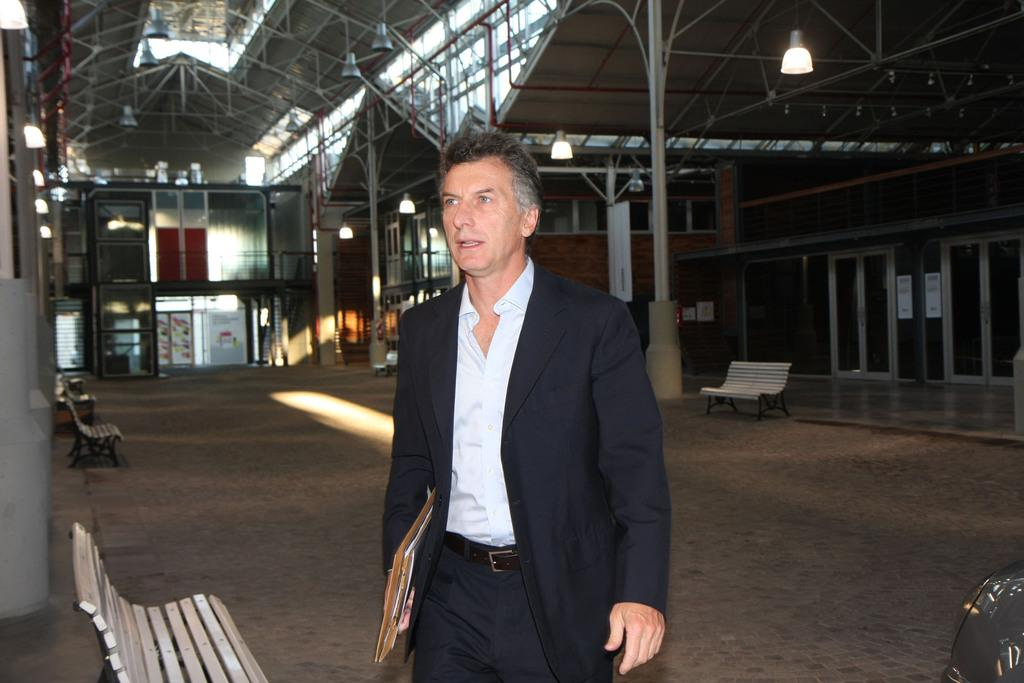Who is present in the image? There is a man in the image. What is the man wearing? The man is wearing a suit. What is the man holding in his hands? The man is holding files in his hands. What can be seen on the path in the image? There are benches on the path in the image. What is visible in the background of the image? There are lights and sheds in the background of the image. What type of drug is the man taking in the image? There is no indication in the image that the man is taking any drug, and therefore no such activity can be observed. 